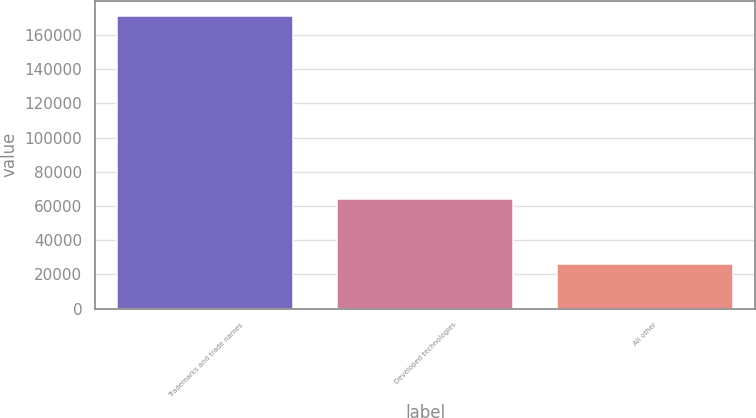Convert chart to OTSL. <chart><loc_0><loc_0><loc_500><loc_500><bar_chart><fcel>Trademarks and trade names<fcel>Developed technologies<fcel>All other<nl><fcel>171390<fcel>63912<fcel>26232<nl></chart> 